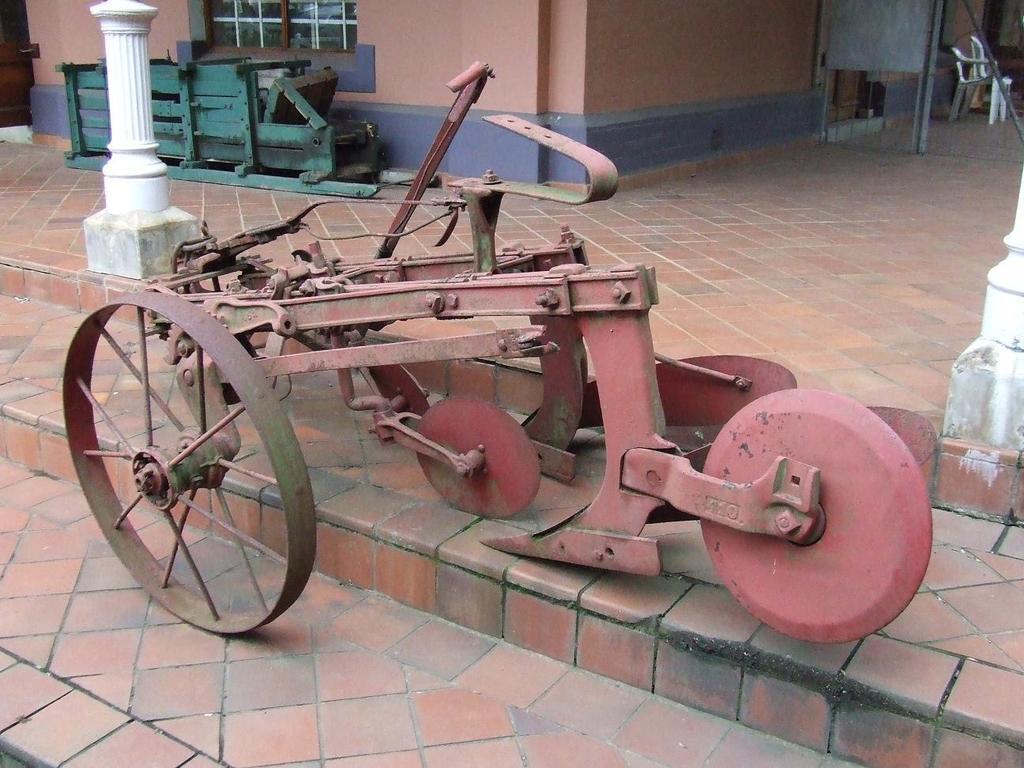Can you describe this image briefly? In this picture we can see a cart on steps, pillar, window, walls and an object on the floor and in the background we can see chairs, some objects. 